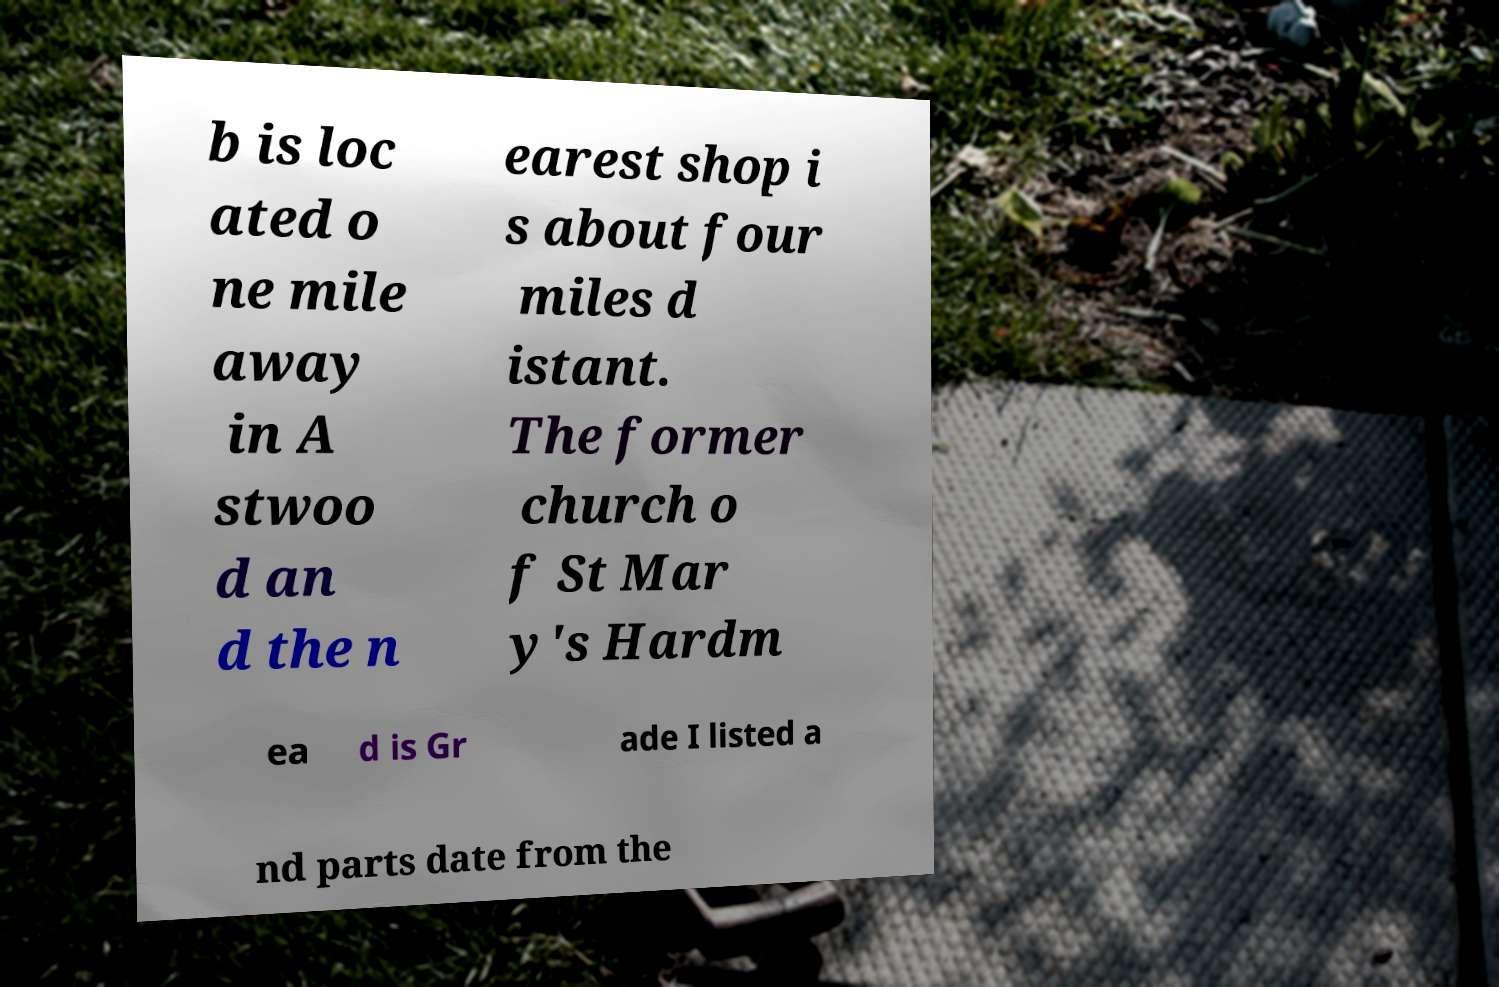I need the written content from this picture converted into text. Can you do that? b is loc ated o ne mile away in A stwoo d an d the n earest shop i s about four miles d istant. The former church o f St Mar y's Hardm ea d is Gr ade I listed a nd parts date from the 